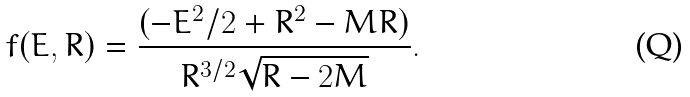Convert formula to latex. <formula><loc_0><loc_0><loc_500><loc_500>f ( E , R ) = \frac { ( - E ^ { 2 } / 2 + R ^ { 2 } - M R ) } { R ^ { 3 / 2 } \sqrt { R - 2 M } } .</formula> 